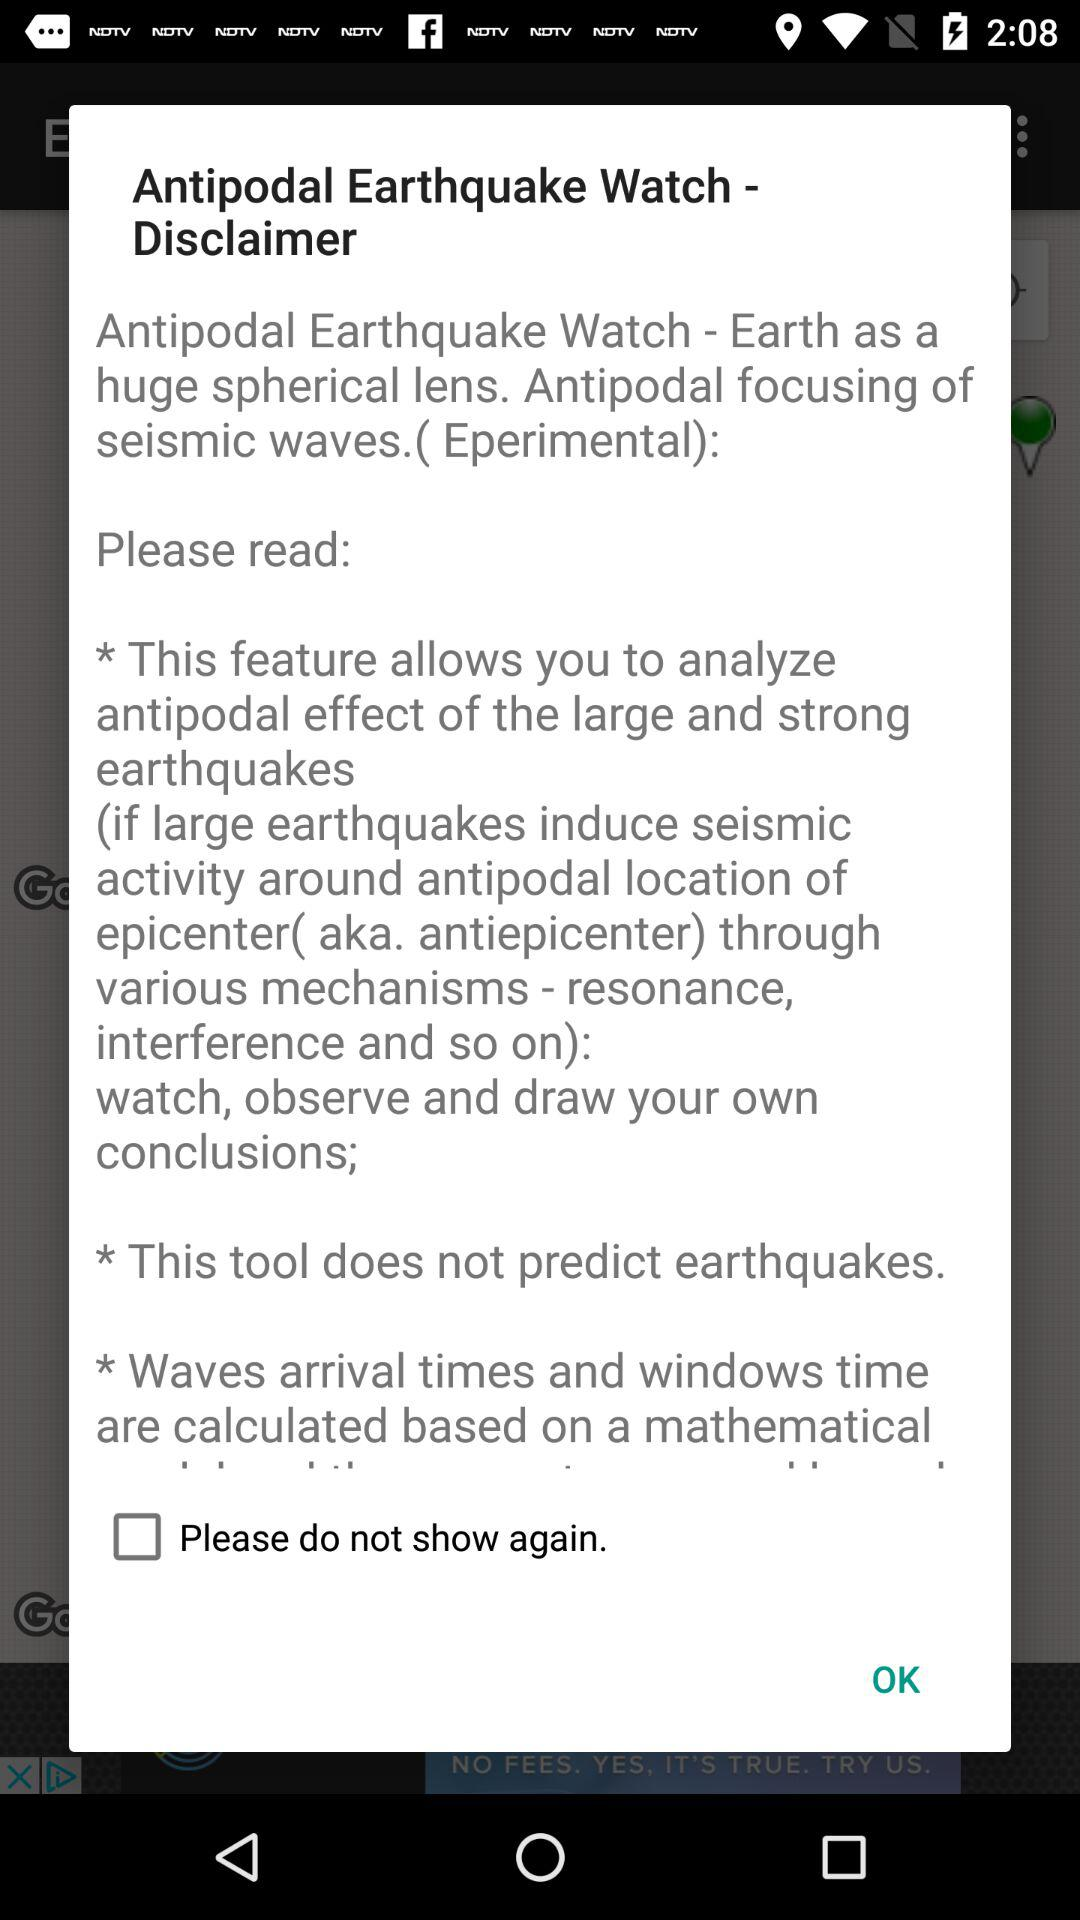What's the status of "Please do not show again"? The status is off. 